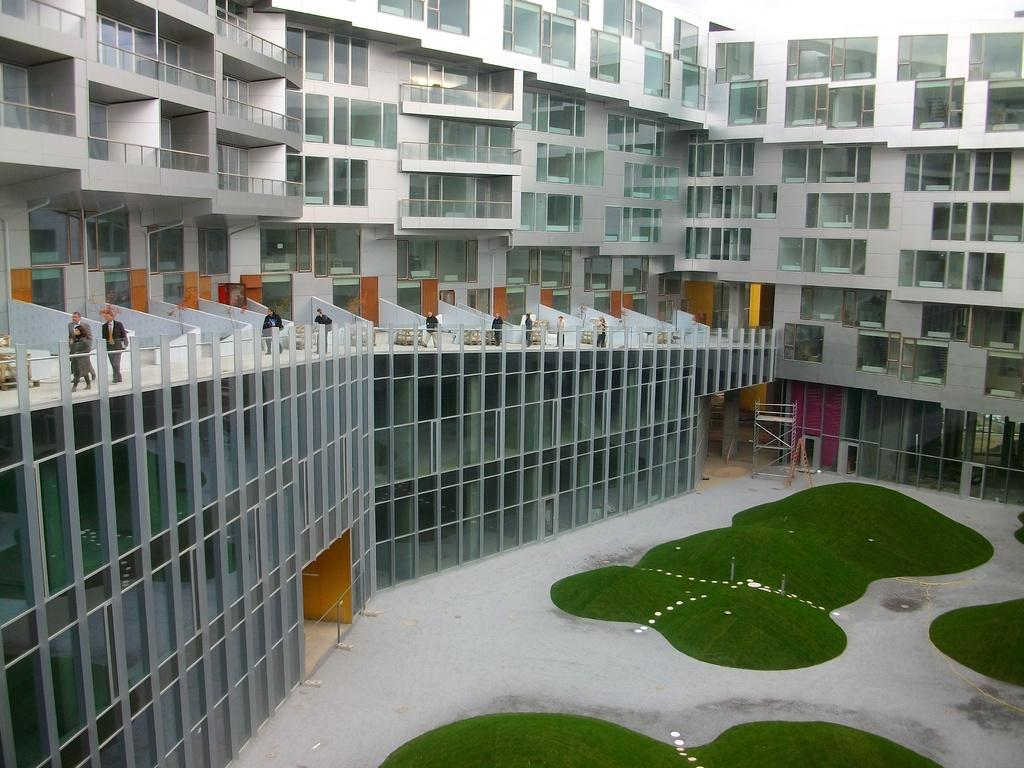What type of structure is visible in the image? There is a building in the image. What are the people in the image doing? People are walking in the image. What type of vegetation is present in the image? There is grass in the image. Where is the hill located in the image? There is no hill present in the image. How many people are sleeping in the image? There are no people sleeping in the image; they are walking. 